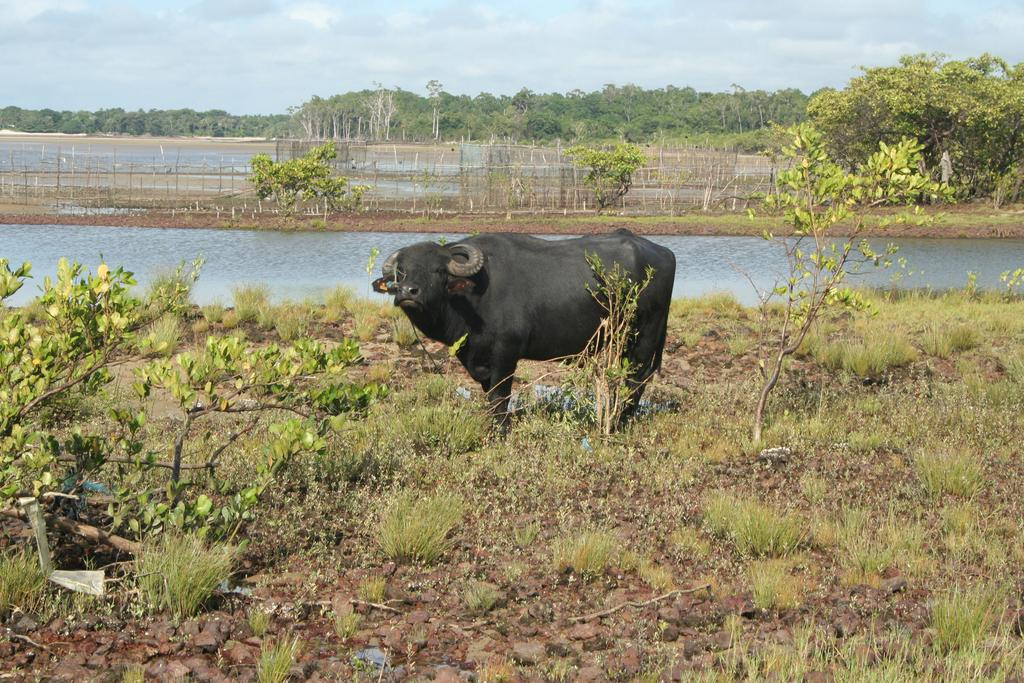What animal is the main subject of the image? There is a buffalo in the image. Where is the buffalo located in the image? The buffalo is standing in the middle of the image. What can be seen in the background of the image? There is water, trees, and a clear sky visible in the background of the image. What type of rock is the buffalo standing on in the image? There is no rock visible in the image; the buffalo is standing on the ground. 